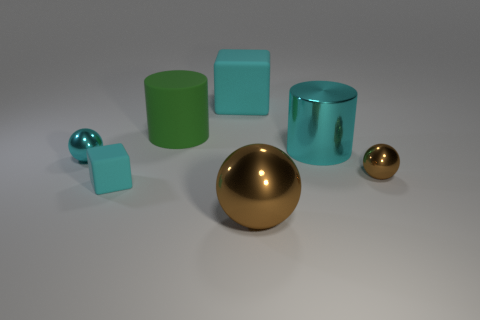Is the tiny rubber block the same color as the big rubber cube?
Provide a succinct answer. Yes. Is there anything else that is the same color as the rubber cylinder?
Ensure brevity in your answer.  No. There is a cyan metallic object to the right of the large object behind the big green rubber thing; how big is it?
Give a very brief answer. Large. There is a tiny sphere on the right side of the large cyan cube; does it have the same color as the big object that is in front of the tiny cyan shiny thing?
Offer a terse response. Yes. There is a matte object that is in front of the cyan shiny sphere; is there a big brown ball behind it?
Offer a very short reply. No. Is the number of balls that are on the left side of the big green rubber cylinder less than the number of small cyan objects behind the large brown shiny object?
Ensure brevity in your answer.  Yes. Is the cyan object right of the large brown ball made of the same material as the large thing in front of the cyan shiny ball?
Ensure brevity in your answer.  Yes. How many small objects are either matte cubes or shiny things?
Provide a succinct answer. 3. What shape is the large cyan thing that is made of the same material as the small brown ball?
Ensure brevity in your answer.  Cylinder. Is the number of cubes behind the large matte cube less than the number of big rubber blocks?
Make the answer very short. Yes. 